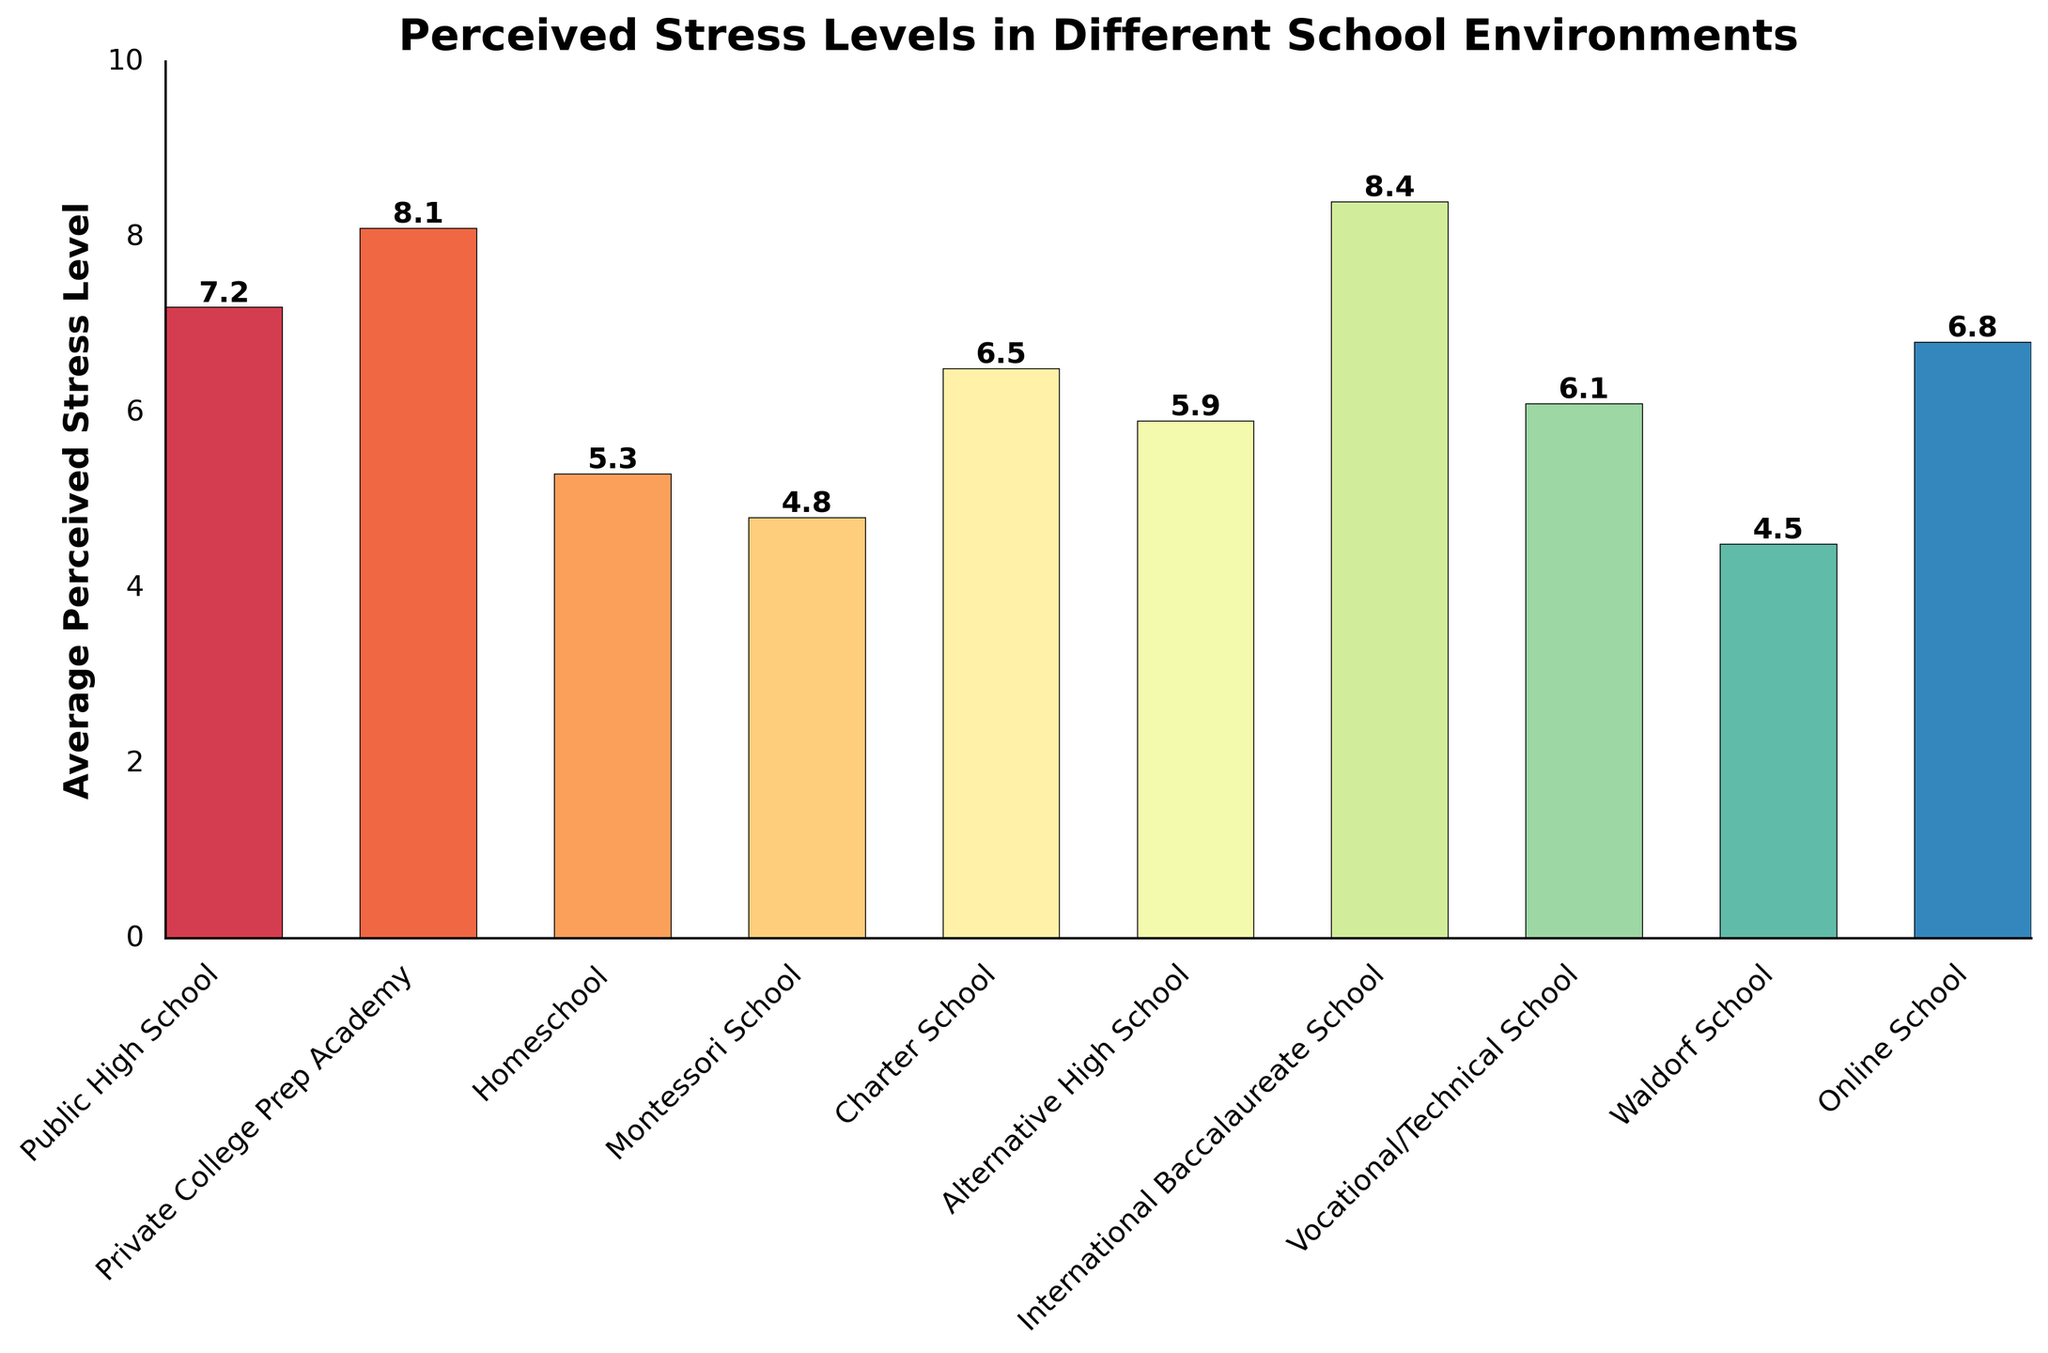Which school type has the highest average perceived stress level? To find the highest average perceived stress level, look at the tallest bar in the chart. The tallest bar represents the International Baccalaureate School.
Answer: International Baccalaureate School What is the difference in the average perceived stress level between Homeschool and Public High School? Look at the heights of the bars corresponding to Homeschool and Public High School. Subtract the Homeschool stress level (5.3) from the Public High School stress level (7.2). The difference is 7.2 - 5.3 = 1.9.
Answer: 1.9 Which school type has a lower average perceived stress level than Charter School but higher than Waldorf School? Find the bars corresponding to Charter School and Waldorf School. The stress levels are 6.5 and 4.5 respectively. We need a school with a stress level between 4.5 and 6.5. The Homeschool stress level is 5.3, which fits this range.
Answer: Homeschool How many school types have an average perceived stress level above 6.0? Count the bars with heights above the 6.0 mark. The school types are Public High School, Private College Prep Academy, International Baccalaureate School, Online School, and Charter School. That's five school types.
Answer: 5 Which school type has the closest average perceived stress level to Online School? Find the bar corresponding to Online School (6.8). The closest stress level to this is Public High School with a stress level of 7.2.
Answer: Public High School What is the sum of the average perceived stress levels of Montessori School, Waldorf School, and Vocational/Technical School? Add the stress levels of the Montessori School (4.8), Waldorf School (4.5), and Vocational/Technical School (6.1). The sum is 4.8 + 4.5 + 6.1 = 15.4.
Answer: 15.4 Which two school types have the smallest difference in average perceived stress levels? Check the bars for the smallest difference in height. The smallest difference is between Public High School (7.2) and Online School (6.8), which is 0.4.
Answer: Public High School and Online School What is the average perceived stress level across all school types? Sum all the stress levels and divide by the number of school types. The sum of stress levels is 7.2 + 8.1 + 5.3 + 4.8 + 6.5 + 5.9 + 8.4 + 6.1 + 4.5 + 6.8 = 63.6. There are 10 school types, so the average is 63.6 / 10 = 6.36.
Answer: 6.36 